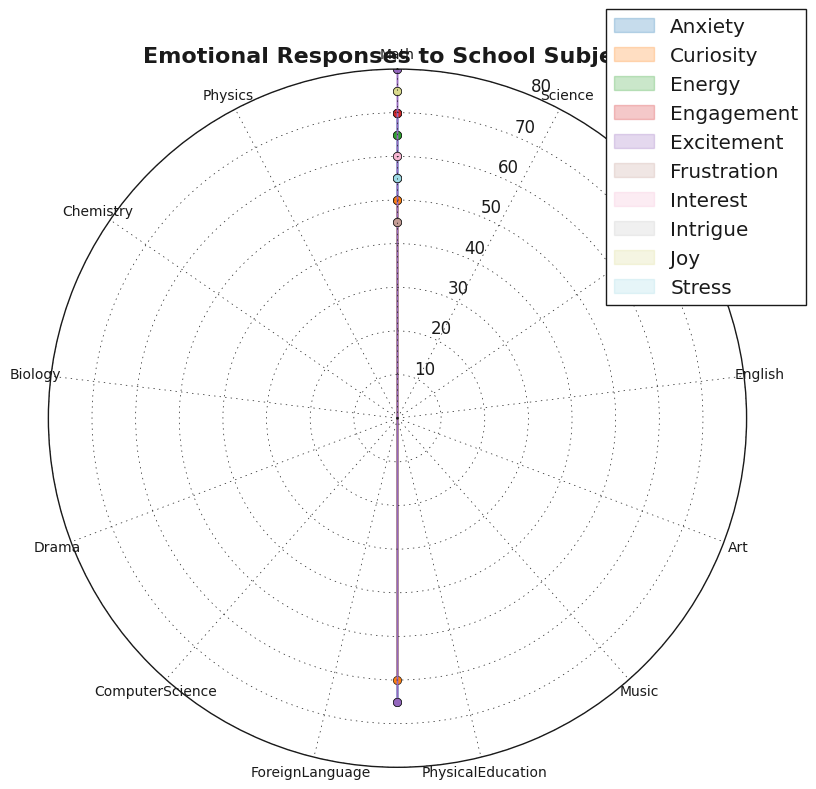Which subject has the highest intensity of excitement? First, identify the subjects associated with the emotional response "Excitement". These are Art and Drama. Next, compare their intensity values: Art has an intensity of 80, and Drama has an intensity of 65. Art has the highest intensity of excitement.
Answer: Art What is the total intensity for subjects associated with anxiety? Identify the subjects related to anxiety: Math and Chemistry. Sum their intensity values: 70 (Math) + 65 (Chemistry) = 135.
Answer: 135 Which emotional response shows a higher intensity: joy for Music or curiosity for Science? Look at the intensity values: Joy for Music has an intensity of 75, while Curiosity for Science has an intensity of 50. Joy for Music has a higher intensity.
Answer: Joy for Music Does any subject have an emotional response of stress, and if so, what is the intensity? Identify the subject associated with stress, which is Foreign Language, and note its intensity, which is 55.
Answer: Yes, 55 Which has a higher intensity: the curiosity for Biology or the engagement for Computer Science? Compare the intensities of curiosity for Biology (60) and engagement for Computer Science (70). Engagement for Computer Science has a higher intensity.
Answer: Engagement for Computer Science What is the average intensity of all subjects related to curiosity? Find the subjects associated with curiosity: Science and Biology. Sum their intensity values and divide by the number of subjects (50+60)/2 = 55.
Answer: 55 Between frustration for English and intrigue for Physics, which one has a lesser intensity? Compare the intensities of frustration for English (45) and intrigue for Physics (55). Frustration for English has a lesser intensity.
Answer: Frustration for English What is the difference in intensity between excitement for Art and energy for Physical Education? Subtract the intensity of energy for Physical Education from the intensity of excitement for Art: 80 (Art) - 65 (Physical Education) = 15.
Answer: 15 Which subject combination shows both excitement but varying degrees of intensity? Identify subjects associated with excitement: Art (80) and Drama (65). Both have excitement but varying degrees of intensity.
Answer: Art and Drama How many subjects have an intensity that exceeds 60? Count the number of subjects with intensities over 60: Math (70), Art (80), Music (75), Physical Education (65), Computer Science (70), Chemistry (65), Drama (65). There are 7 subjects.
Answer: 7 